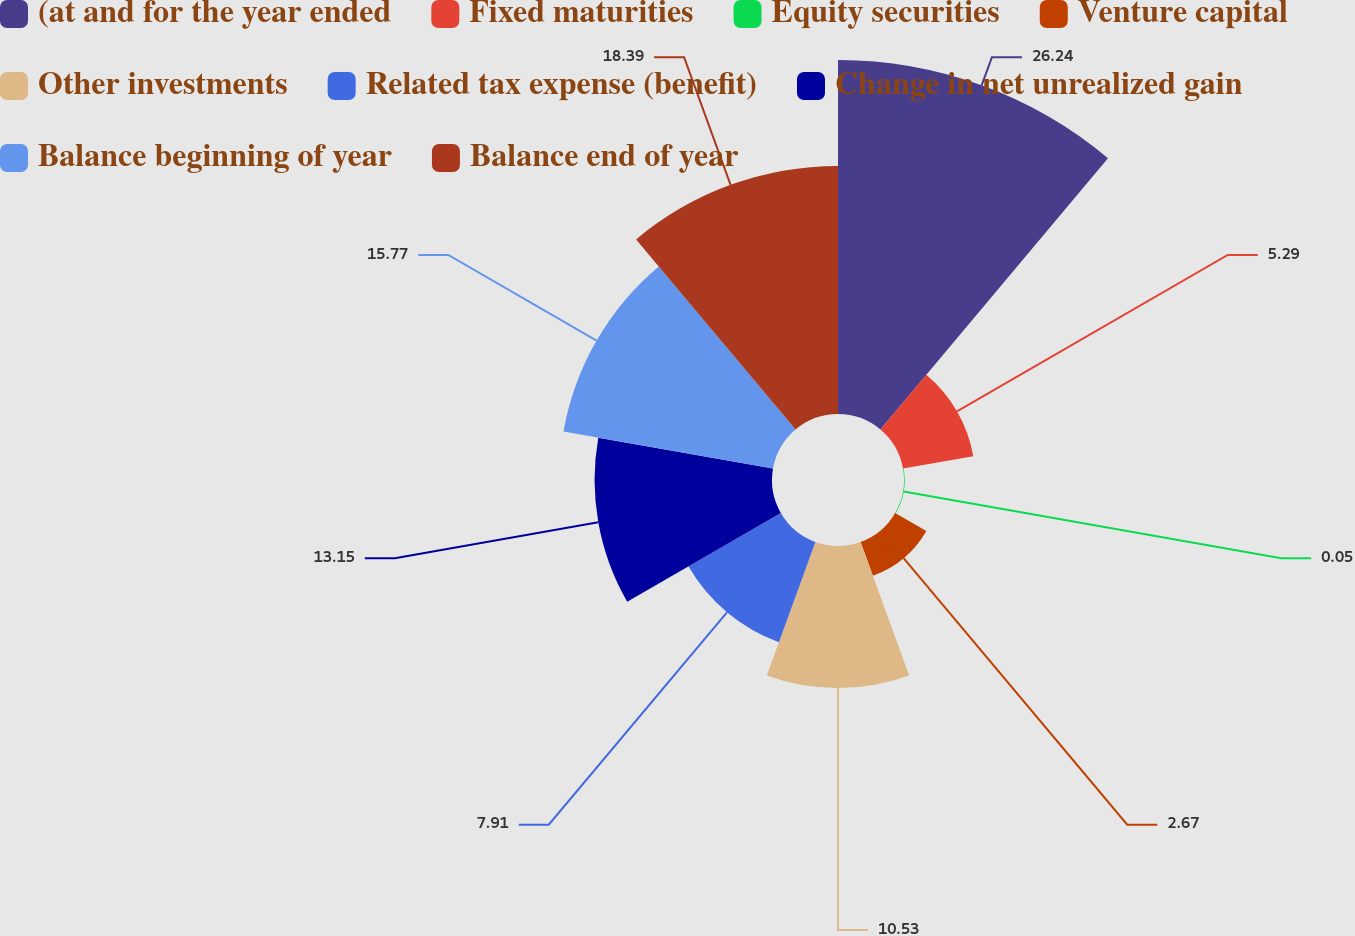Convert chart to OTSL. <chart><loc_0><loc_0><loc_500><loc_500><pie_chart><fcel>(at and for the year ended<fcel>Fixed maturities<fcel>Equity securities<fcel>Venture capital<fcel>Other investments<fcel>Related tax expense (benefit)<fcel>Change in net unrealized gain<fcel>Balance beginning of year<fcel>Balance end of year<nl><fcel>26.24%<fcel>5.29%<fcel>0.05%<fcel>2.67%<fcel>10.53%<fcel>7.91%<fcel>13.15%<fcel>15.77%<fcel>18.39%<nl></chart> 